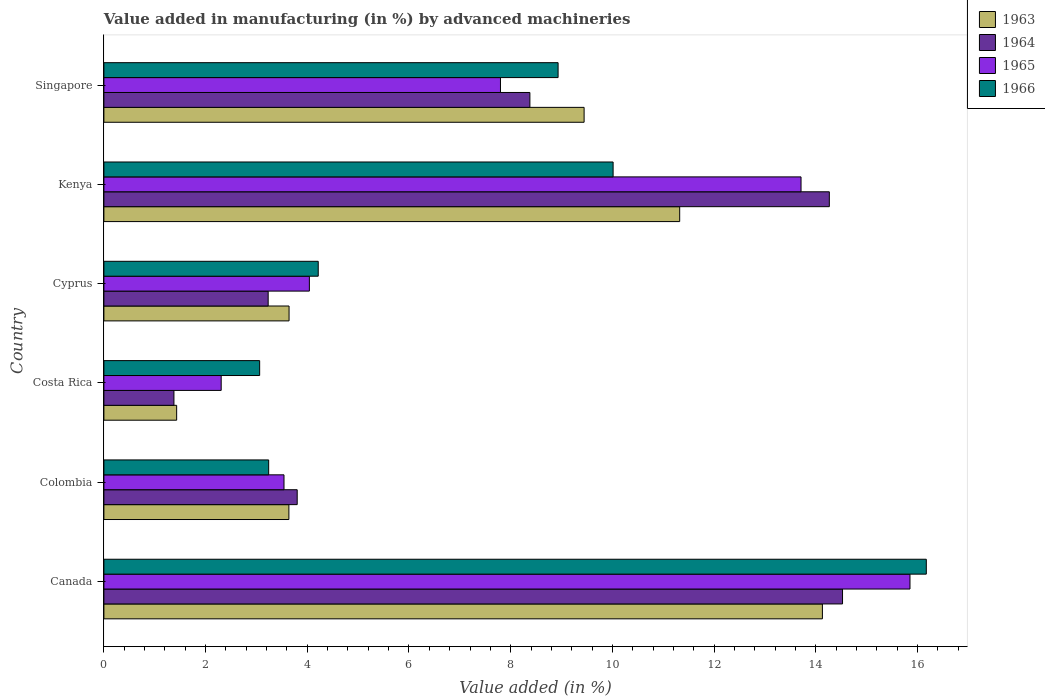How many groups of bars are there?
Offer a very short reply. 6. Are the number of bars on each tick of the Y-axis equal?
Your answer should be very brief. Yes. In how many cases, is the number of bars for a given country not equal to the number of legend labels?
Ensure brevity in your answer.  0. What is the percentage of value added in manufacturing by advanced machineries in 1964 in Canada?
Offer a terse response. 14.53. Across all countries, what is the maximum percentage of value added in manufacturing by advanced machineries in 1966?
Make the answer very short. 16.17. Across all countries, what is the minimum percentage of value added in manufacturing by advanced machineries in 1966?
Your response must be concise. 3.06. In which country was the percentage of value added in manufacturing by advanced machineries in 1965 maximum?
Your answer should be compact. Canada. What is the total percentage of value added in manufacturing by advanced machineries in 1963 in the graph?
Keep it short and to the point. 43.61. What is the difference between the percentage of value added in manufacturing by advanced machineries in 1966 in Canada and that in Singapore?
Offer a very short reply. 7.24. What is the difference between the percentage of value added in manufacturing by advanced machineries in 1966 in Costa Rica and the percentage of value added in manufacturing by advanced machineries in 1965 in Canada?
Give a very brief answer. -12.79. What is the average percentage of value added in manufacturing by advanced machineries in 1963 per country?
Offer a very short reply. 7.27. What is the difference between the percentage of value added in manufacturing by advanced machineries in 1964 and percentage of value added in manufacturing by advanced machineries in 1963 in Costa Rica?
Your answer should be compact. -0.05. In how many countries, is the percentage of value added in manufacturing by advanced machineries in 1964 greater than 12.4 %?
Make the answer very short. 2. What is the ratio of the percentage of value added in manufacturing by advanced machineries in 1966 in Cyprus to that in Singapore?
Your answer should be very brief. 0.47. Is the percentage of value added in manufacturing by advanced machineries in 1966 in Colombia less than that in Singapore?
Your answer should be very brief. Yes. Is the difference between the percentage of value added in manufacturing by advanced machineries in 1964 in Cyprus and Kenya greater than the difference between the percentage of value added in manufacturing by advanced machineries in 1963 in Cyprus and Kenya?
Your response must be concise. No. What is the difference between the highest and the second highest percentage of value added in manufacturing by advanced machineries in 1964?
Your answer should be very brief. 0.26. What is the difference between the highest and the lowest percentage of value added in manufacturing by advanced machineries in 1963?
Keep it short and to the point. 12.7. Is the sum of the percentage of value added in manufacturing by advanced machineries in 1964 in Kenya and Singapore greater than the maximum percentage of value added in manufacturing by advanced machineries in 1966 across all countries?
Ensure brevity in your answer.  Yes. Is it the case that in every country, the sum of the percentage of value added in manufacturing by advanced machineries in 1963 and percentage of value added in manufacturing by advanced machineries in 1964 is greater than the sum of percentage of value added in manufacturing by advanced machineries in 1965 and percentage of value added in manufacturing by advanced machineries in 1966?
Give a very brief answer. No. What does the 2nd bar from the top in Costa Rica represents?
Keep it short and to the point. 1965. What does the 3rd bar from the bottom in Kenya represents?
Give a very brief answer. 1965. How many countries are there in the graph?
Your answer should be compact. 6. Are the values on the major ticks of X-axis written in scientific E-notation?
Give a very brief answer. No. How many legend labels are there?
Provide a short and direct response. 4. What is the title of the graph?
Your answer should be very brief. Value added in manufacturing (in %) by advanced machineries. Does "2003" appear as one of the legend labels in the graph?
Offer a very short reply. No. What is the label or title of the X-axis?
Offer a very short reply. Value added (in %). What is the label or title of the Y-axis?
Your response must be concise. Country. What is the Value added (in %) of 1963 in Canada?
Make the answer very short. 14.13. What is the Value added (in %) of 1964 in Canada?
Keep it short and to the point. 14.53. What is the Value added (in %) of 1965 in Canada?
Make the answer very short. 15.85. What is the Value added (in %) in 1966 in Canada?
Keep it short and to the point. 16.17. What is the Value added (in %) of 1963 in Colombia?
Offer a terse response. 3.64. What is the Value added (in %) of 1964 in Colombia?
Your answer should be very brief. 3.8. What is the Value added (in %) in 1965 in Colombia?
Offer a very short reply. 3.54. What is the Value added (in %) of 1966 in Colombia?
Give a very brief answer. 3.24. What is the Value added (in %) in 1963 in Costa Rica?
Ensure brevity in your answer.  1.43. What is the Value added (in %) of 1964 in Costa Rica?
Your response must be concise. 1.38. What is the Value added (in %) of 1965 in Costa Rica?
Offer a terse response. 2.31. What is the Value added (in %) in 1966 in Costa Rica?
Your answer should be very brief. 3.06. What is the Value added (in %) of 1963 in Cyprus?
Provide a short and direct response. 3.64. What is the Value added (in %) of 1964 in Cyprus?
Offer a terse response. 3.23. What is the Value added (in %) of 1965 in Cyprus?
Keep it short and to the point. 4.04. What is the Value added (in %) in 1966 in Cyprus?
Your response must be concise. 4.22. What is the Value added (in %) in 1963 in Kenya?
Make the answer very short. 11.32. What is the Value added (in %) of 1964 in Kenya?
Provide a succinct answer. 14.27. What is the Value added (in %) of 1965 in Kenya?
Your response must be concise. 13.71. What is the Value added (in %) of 1966 in Kenya?
Offer a very short reply. 10.01. What is the Value added (in %) in 1963 in Singapore?
Give a very brief answer. 9.44. What is the Value added (in %) in 1964 in Singapore?
Your answer should be very brief. 8.38. What is the Value added (in %) of 1965 in Singapore?
Provide a short and direct response. 7.8. What is the Value added (in %) of 1966 in Singapore?
Offer a terse response. 8.93. Across all countries, what is the maximum Value added (in %) in 1963?
Keep it short and to the point. 14.13. Across all countries, what is the maximum Value added (in %) in 1964?
Offer a terse response. 14.53. Across all countries, what is the maximum Value added (in %) of 1965?
Your answer should be very brief. 15.85. Across all countries, what is the maximum Value added (in %) of 1966?
Keep it short and to the point. 16.17. Across all countries, what is the minimum Value added (in %) in 1963?
Ensure brevity in your answer.  1.43. Across all countries, what is the minimum Value added (in %) in 1964?
Keep it short and to the point. 1.38. Across all countries, what is the minimum Value added (in %) of 1965?
Your answer should be compact. 2.31. Across all countries, what is the minimum Value added (in %) of 1966?
Ensure brevity in your answer.  3.06. What is the total Value added (in %) in 1963 in the graph?
Give a very brief answer. 43.61. What is the total Value added (in %) in 1964 in the graph?
Provide a short and direct response. 45.58. What is the total Value added (in %) in 1965 in the graph?
Make the answer very short. 47.25. What is the total Value added (in %) in 1966 in the graph?
Your response must be concise. 45.64. What is the difference between the Value added (in %) in 1963 in Canada and that in Colombia?
Offer a very short reply. 10.49. What is the difference between the Value added (in %) in 1964 in Canada and that in Colombia?
Keep it short and to the point. 10.72. What is the difference between the Value added (in %) in 1965 in Canada and that in Colombia?
Make the answer very short. 12.31. What is the difference between the Value added (in %) in 1966 in Canada and that in Colombia?
Provide a succinct answer. 12.93. What is the difference between the Value added (in %) of 1963 in Canada and that in Costa Rica?
Your answer should be very brief. 12.7. What is the difference between the Value added (in %) in 1964 in Canada and that in Costa Rica?
Give a very brief answer. 13.15. What is the difference between the Value added (in %) in 1965 in Canada and that in Costa Rica?
Offer a terse response. 13.55. What is the difference between the Value added (in %) in 1966 in Canada and that in Costa Rica?
Give a very brief answer. 13.11. What is the difference between the Value added (in %) of 1963 in Canada and that in Cyprus?
Make the answer very short. 10.49. What is the difference between the Value added (in %) of 1964 in Canada and that in Cyprus?
Provide a short and direct response. 11.3. What is the difference between the Value added (in %) of 1965 in Canada and that in Cyprus?
Your response must be concise. 11.81. What is the difference between the Value added (in %) in 1966 in Canada and that in Cyprus?
Your response must be concise. 11.96. What is the difference between the Value added (in %) in 1963 in Canada and that in Kenya?
Offer a very short reply. 2.81. What is the difference between the Value added (in %) of 1964 in Canada and that in Kenya?
Keep it short and to the point. 0.26. What is the difference between the Value added (in %) in 1965 in Canada and that in Kenya?
Offer a terse response. 2.14. What is the difference between the Value added (in %) of 1966 in Canada and that in Kenya?
Your response must be concise. 6.16. What is the difference between the Value added (in %) in 1963 in Canada and that in Singapore?
Your answer should be compact. 4.69. What is the difference between the Value added (in %) of 1964 in Canada and that in Singapore?
Make the answer very short. 6.15. What is the difference between the Value added (in %) of 1965 in Canada and that in Singapore?
Offer a terse response. 8.05. What is the difference between the Value added (in %) of 1966 in Canada and that in Singapore?
Keep it short and to the point. 7.24. What is the difference between the Value added (in %) of 1963 in Colombia and that in Costa Rica?
Your answer should be very brief. 2.21. What is the difference between the Value added (in %) in 1964 in Colombia and that in Costa Rica?
Your response must be concise. 2.42. What is the difference between the Value added (in %) of 1965 in Colombia and that in Costa Rica?
Ensure brevity in your answer.  1.24. What is the difference between the Value added (in %) in 1966 in Colombia and that in Costa Rica?
Ensure brevity in your answer.  0.18. What is the difference between the Value added (in %) of 1963 in Colombia and that in Cyprus?
Provide a short and direct response. -0. What is the difference between the Value added (in %) of 1964 in Colombia and that in Cyprus?
Provide a succinct answer. 0.57. What is the difference between the Value added (in %) in 1965 in Colombia and that in Cyprus?
Offer a terse response. -0.5. What is the difference between the Value added (in %) of 1966 in Colombia and that in Cyprus?
Your answer should be very brief. -0.97. What is the difference between the Value added (in %) in 1963 in Colombia and that in Kenya?
Your answer should be very brief. -7.69. What is the difference between the Value added (in %) of 1964 in Colombia and that in Kenya?
Offer a very short reply. -10.47. What is the difference between the Value added (in %) of 1965 in Colombia and that in Kenya?
Offer a terse response. -10.17. What is the difference between the Value added (in %) in 1966 in Colombia and that in Kenya?
Ensure brevity in your answer.  -6.77. What is the difference between the Value added (in %) of 1963 in Colombia and that in Singapore?
Offer a very short reply. -5.81. What is the difference between the Value added (in %) of 1964 in Colombia and that in Singapore?
Your response must be concise. -4.58. What is the difference between the Value added (in %) in 1965 in Colombia and that in Singapore?
Make the answer very short. -4.26. What is the difference between the Value added (in %) in 1966 in Colombia and that in Singapore?
Your answer should be compact. -5.69. What is the difference between the Value added (in %) in 1963 in Costa Rica and that in Cyprus?
Provide a short and direct response. -2.21. What is the difference between the Value added (in %) in 1964 in Costa Rica and that in Cyprus?
Offer a terse response. -1.85. What is the difference between the Value added (in %) in 1965 in Costa Rica and that in Cyprus?
Your response must be concise. -1.73. What is the difference between the Value added (in %) in 1966 in Costa Rica and that in Cyprus?
Keep it short and to the point. -1.15. What is the difference between the Value added (in %) in 1963 in Costa Rica and that in Kenya?
Offer a terse response. -9.89. What is the difference between the Value added (in %) in 1964 in Costa Rica and that in Kenya?
Give a very brief answer. -12.89. What is the difference between the Value added (in %) in 1965 in Costa Rica and that in Kenya?
Offer a very short reply. -11.4. What is the difference between the Value added (in %) in 1966 in Costa Rica and that in Kenya?
Your answer should be compact. -6.95. What is the difference between the Value added (in %) in 1963 in Costa Rica and that in Singapore?
Provide a short and direct response. -8.01. What is the difference between the Value added (in %) in 1964 in Costa Rica and that in Singapore?
Ensure brevity in your answer.  -7. What is the difference between the Value added (in %) of 1965 in Costa Rica and that in Singapore?
Provide a succinct answer. -5.49. What is the difference between the Value added (in %) of 1966 in Costa Rica and that in Singapore?
Your answer should be compact. -5.87. What is the difference between the Value added (in %) in 1963 in Cyprus and that in Kenya?
Offer a very short reply. -7.68. What is the difference between the Value added (in %) of 1964 in Cyprus and that in Kenya?
Ensure brevity in your answer.  -11.04. What is the difference between the Value added (in %) of 1965 in Cyprus and that in Kenya?
Ensure brevity in your answer.  -9.67. What is the difference between the Value added (in %) in 1966 in Cyprus and that in Kenya?
Offer a terse response. -5.8. What is the difference between the Value added (in %) in 1963 in Cyprus and that in Singapore?
Provide a short and direct response. -5.8. What is the difference between the Value added (in %) in 1964 in Cyprus and that in Singapore?
Your response must be concise. -5.15. What is the difference between the Value added (in %) in 1965 in Cyprus and that in Singapore?
Offer a terse response. -3.76. What is the difference between the Value added (in %) of 1966 in Cyprus and that in Singapore?
Ensure brevity in your answer.  -4.72. What is the difference between the Value added (in %) of 1963 in Kenya and that in Singapore?
Give a very brief answer. 1.88. What is the difference between the Value added (in %) in 1964 in Kenya and that in Singapore?
Your answer should be very brief. 5.89. What is the difference between the Value added (in %) in 1965 in Kenya and that in Singapore?
Your response must be concise. 5.91. What is the difference between the Value added (in %) of 1966 in Kenya and that in Singapore?
Ensure brevity in your answer.  1.08. What is the difference between the Value added (in %) of 1963 in Canada and the Value added (in %) of 1964 in Colombia?
Your answer should be very brief. 10.33. What is the difference between the Value added (in %) of 1963 in Canada and the Value added (in %) of 1965 in Colombia?
Give a very brief answer. 10.59. What is the difference between the Value added (in %) of 1963 in Canada and the Value added (in %) of 1966 in Colombia?
Provide a succinct answer. 10.89. What is the difference between the Value added (in %) of 1964 in Canada and the Value added (in %) of 1965 in Colombia?
Make the answer very short. 10.98. What is the difference between the Value added (in %) in 1964 in Canada and the Value added (in %) in 1966 in Colombia?
Make the answer very short. 11.29. What is the difference between the Value added (in %) of 1965 in Canada and the Value added (in %) of 1966 in Colombia?
Provide a succinct answer. 12.61. What is the difference between the Value added (in %) of 1963 in Canada and the Value added (in %) of 1964 in Costa Rica?
Keep it short and to the point. 12.75. What is the difference between the Value added (in %) of 1963 in Canada and the Value added (in %) of 1965 in Costa Rica?
Ensure brevity in your answer.  11.82. What is the difference between the Value added (in %) of 1963 in Canada and the Value added (in %) of 1966 in Costa Rica?
Provide a short and direct response. 11.07. What is the difference between the Value added (in %) in 1964 in Canada and the Value added (in %) in 1965 in Costa Rica?
Offer a terse response. 12.22. What is the difference between the Value added (in %) in 1964 in Canada and the Value added (in %) in 1966 in Costa Rica?
Ensure brevity in your answer.  11.46. What is the difference between the Value added (in %) in 1965 in Canada and the Value added (in %) in 1966 in Costa Rica?
Provide a short and direct response. 12.79. What is the difference between the Value added (in %) in 1963 in Canada and the Value added (in %) in 1964 in Cyprus?
Your answer should be very brief. 10.9. What is the difference between the Value added (in %) of 1963 in Canada and the Value added (in %) of 1965 in Cyprus?
Your response must be concise. 10.09. What is the difference between the Value added (in %) in 1963 in Canada and the Value added (in %) in 1966 in Cyprus?
Your answer should be very brief. 9.92. What is the difference between the Value added (in %) in 1964 in Canada and the Value added (in %) in 1965 in Cyprus?
Make the answer very short. 10.49. What is the difference between the Value added (in %) of 1964 in Canada and the Value added (in %) of 1966 in Cyprus?
Your answer should be compact. 10.31. What is the difference between the Value added (in %) in 1965 in Canada and the Value added (in %) in 1966 in Cyprus?
Give a very brief answer. 11.64. What is the difference between the Value added (in %) in 1963 in Canada and the Value added (in %) in 1964 in Kenya?
Offer a terse response. -0.14. What is the difference between the Value added (in %) of 1963 in Canada and the Value added (in %) of 1965 in Kenya?
Provide a short and direct response. 0.42. What is the difference between the Value added (in %) in 1963 in Canada and the Value added (in %) in 1966 in Kenya?
Give a very brief answer. 4.12. What is the difference between the Value added (in %) in 1964 in Canada and the Value added (in %) in 1965 in Kenya?
Give a very brief answer. 0.82. What is the difference between the Value added (in %) in 1964 in Canada and the Value added (in %) in 1966 in Kenya?
Provide a succinct answer. 4.51. What is the difference between the Value added (in %) of 1965 in Canada and the Value added (in %) of 1966 in Kenya?
Offer a very short reply. 5.84. What is the difference between the Value added (in %) in 1963 in Canada and the Value added (in %) in 1964 in Singapore?
Provide a succinct answer. 5.75. What is the difference between the Value added (in %) of 1963 in Canada and the Value added (in %) of 1965 in Singapore?
Give a very brief answer. 6.33. What is the difference between the Value added (in %) in 1963 in Canada and the Value added (in %) in 1966 in Singapore?
Your answer should be compact. 5.2. What is the difference between the Value added (in %) of 1964 in Canada and the Value added (in %) of 1965 in Singapore?
Offer a very short reply. 6.73. What is the difference between the Value added (in %) in 1964 in Canada and the Value added (in %) in 1966 in Singapore?
Your answer should be compact. 5.59. What is the difference between the Value added (in %) in 1965 in Canada and the Value added (in %) in 1966 in Singapore?
Give a very brief answer. 6.92. What is the difference between the Value added (in %) of 1963 in Colombia and the Value added (in %) of 1964 in Costa Rica?
Your answer should be very brief. 2.26. What is the difference between the Value added (in %) in 1963 in Colombia and the Value added (in %) in 1965 in Costa Rica?
Provide a short and direct response. 1.33. What is the difference between the Value added (in %) in 1963 in Colombia and the Value added (in %) in 1966 in Costa Rica?
Provide a succinct answer. 0.57. What is the difference between the Value added (in %) of 1964 in Colombia and the Value added (in %) of 1965 in Costa Rica?
Your answer should be compact. 1.49. What is the difference between the Value added (in %) of 1964 in Colombia and the Value added (in %) of 1966 in Costa Rica?
Ensure brevity in your answer.  0.74. What is the difference between the Value added (in %) of 1965 in Colombia and the Value added (in %) of 1966 in Costa Rica?
Ensure brevity in your answer.  0.48. What is the difference between the Value added (in %) in 1963 in Colombia and the Value added (in %) in 1964 in Cyprus?
Ensure brevity in your answer.  0.41. What is the difference between the Value added (in %) of 1963 in Colombia and the Value added (in %) of 1965 in Cyprus?
Make the answer very short. -0.4. What is the difference between the Value added (in %) of 1963 in Colombia and the Value added (in %) of 1966 in Cyprus?
Your response must be concise. -0.58. What is the difference between the Value added (in %) of 1964 in Colombia and the Value added (in %) of 1965 in Cyprus?
Your response must be concise. -0.24. What is the difference between the Value added (in %) of 1964 in Colombia and the Value added (in %) of 1966 in Cyprus?
Provide a short and direct response. -0.41. What is the difference between the Value added (in %) in 1965 in Colombia and the Value added (in %) in 1966 in Cyprus?
Offer a terse response. -0.67. What is the difference between the Value added (in %) of 1963 in Colombia and the Value added (in %) of 1964 in Kenya?
Your answer should be very brief. -10.63. What is the difference between the Value added (in %) in 1963 in Colombia and the Value added (in %) in 1965 in Kenya?
Your answer should be compact. -10.07. What is the difference between the Value added (in %) in 1963 in Colombia and the Value added (in %) in 1966 in Kenya?
Provide a succinct answer. -6.38. What is the difference between the Value added (in %) in 1964 in Colombia and the Value added (in %) in 1965 in Kenya?
Make the answer very short. -9.91. What is the difference between the Value added (in %) of 1964 in Colombia and the Value added (in %) of 1966 in Kenya?
Provide a succinct answer. -6.21. What is the difference between the Value added (in %) of 1965 in Colombia and the Value added (in %) of 1966 in Kenya?
Make the answer very short. -6.47. What is the difference between the Value added (in %) in 1963 in Colombia and the Value added (in %) in 1964 in Singapore?
Your answer should be compact. -4.74. What is the difference between the Value added (in %) of 1963 in Colombia and the Value added (in %) of 1965 in Singapore?
Your answer should be very brief. -4.16. What is the difference between the Value added (in %) in 1963 in Colombia and the Value added (in %) in 1966 in Singapore?
Your answer should be very brief. -5.29. What is the difference between the Value added (in %) in 1964 in Colombia and the Value added (in %) in 1965 in Singapore?
Your response must be concise. -4. What is the difference between the Value added (in %) of 1964 in Colombia and the Value added (in %) of 1966 in Singapore?
Make the answer very short. -5.13. What is the difference between the Value added (in %) of 1965 in Colombia and the Value added (in %) of 1966 in Singapore?
Your response must be concise. -5.39. What is the difference between the Value added (in %) in 1963 in Costa Rica and the Value added (in %) in 1964 in Cyprus?
Your response must be concise. -1.8. What is the difference between the Value added (in %) in 1963 in Costa Rica and the Value added (in %) in 1965 in Cyprus?
Make the answer very short. -2.61. What is the difference between the Value added (in %) in 1963 in Costa Rica and the Value added (in %) in 1966 in Cyprus?
Keep it short and to the point. -2.78. What is the difference between the Value added (in %) in 1964 in Costa Rica and the Value added (in %) in 1965 in Cyprus?
Give a very brief answer. -2.66. What is the difference between the Value added (in %) of 1964 in Costa Rica and the Value added (in %) of 1966 in Cyprus?
Provide a short and direct response. -2.84. What is the difference between the Value added (in %) of 1965 in Costa Rica and the Value added (in %) of 1966 in Cyprus?
Your answer should be very brief. -1.91. What is the difference between the Value added (in %) in 1963 in Costa Rica and the Value added (in %) in 1964 in Kenya?
Make the answer very short. -12.84. What is the difference between the Value added (in %) in 1963 in Costa Rica and the Value added (in %) in 1965 in Kenya?
Give a very brief answer. -12.28. What is the difference between the Value added (in %) in 1963 in Costa Rica and the Value added (in %) in 1966 in Kenya?
Make the answer very short. -8.58. What is the difference between the Value added (in %) of 1964 in Costa Rica and the Value added (in %) of 1965 in Kenya?
Give a very brief answer. -12.33. What is the difference between the Value added (in %) of 1964 in Costa Rica and the Value added (in %) of 1966 in Kenya?
Provide a short and direct response. -8.64. What is the difference between the Value added (in %) in 1965 in Costa Rica and the Value added (in %) in 1966 in Kenya?
Give a very brief answer. -7.71. What is the difference between the Value added (in %) of 1963 in Costa Rica and the Value added (in %) of 1964 in Singapore?
Provide a short and direct response. -6.95. What is the difference between the Value added (in %) in 1963 in Costa Rica and the Value added (in %) in 1965 in Singapore?
Provide a succinct answer. -6.37. What is the difference between the Value added (in %) of 1963 in Costa Rica and the Value added (in %) of 1966 in Singapore?
Provide a succinct answer. -7.5. What is the difference between the Value added (in %) in 1964 in Costa Rica and the Value added (in %) in 1965 in Singapore?
Ensure brevity in your answer.  -6.42. What is the difference between the Value added (in %) of 1964 in Costa Rica and the Value added (in %) of 1966 in Singapore?
Keep it short and to the point. -7.55. What is the difference between the Value added (in %) of 1965 in Costa Rica and the Value added (in %) of 1966 in Singapore?
Your response must be concise. -6.63. What is the difference between the Value added (in %) in 1963 in Cyprus and the Value added (in %) in 1964 in Kenya?
Offer a terse response. -10.63. What is the difference between the Value added (in %) in 1963 in Cyprus and the Value added (in %) in 1965 in Kenya?
Offer a terse response. -10.07. What is the difference between the Value added (in %) in 1963 in Cyprus and the Value added (in %) in 1966 in Kenya?
Your response must be concise. -6.37. What is the difference between the Value added (in %) of 1964 in Cyprus and the Value added (in %) of 1965 in Kenya?
Make the answer very short. -10.48. What is the difference between the Value added (in %) in 1964 in Cyprus and the Value added (in %) in 1966 in Kenya?
Ensure brevity in your answer.  -6.78. What is the difference between the Value added (in %) of 1965 in Cyprus and the Value added (in %) of 1966 in Kenya?
Offer a very short reply. -5.97. What is the difference between the Value added (in %) of 1963 in Cyprus and the Value added (in %) of 1964 in Singapore?
Provide a succinct answer. -4.74. What is the difference between the Value added (in %) in 1963 in Cyprus and the Value added (in %) in 1965 in Singapore?
Your response must be concise. -4.16. What is the difference between the Value added (in %) of 1963 in Cyprus and the Value added (in %) of 1966 in Singapore?
Offer a terse response. -5.29. What is the difference between the Value added (in %) of 1964 in Cyprus and the Value added (in %) of 1965 in Singapore?
Your response must be concise. -4.57. What is the difference between the Value added (in %) of 1964 in Cyprus and the Value added (in %) of 1966 in Singapore?
Provide a succinct answer. -5.7. What is the difference between the Value added (in %) of 1965 in Cyprus and the Value added (in %) of 1966 in Singapore?
Your answer should be compact. -4.89. What is the difference between the Value added (in %) in 1963 in Kenya and the Value added (in %) in 1964 in Singapore?
Provide a succinct answer. 2.95. What is the difference between the Value added (in %) in 1963 in Kenya and the Value added (in %) in 1965 in Singapore?
Offer a terse response. 3.52. What is the difference between the Value added (in %) of 1963 in Kenya and the Value added (in %) of 1966 in Singapore?
Provide a succinct answer. 2.39. What is the difference between the Value added (in %) in 1964 in Kenya and the Value added (in %) in 1965 in Singapore?
Your answer should be very brief. 6.47. What is the difference between the Value added (in %) in 1964 in Kenya and the Value added (in %) in 1966 in Singapore?
Offer a terse response. 5.33. What is the difference between the Value added (in %) of 1965 in Kenya and the Value added (in %) of 1966 in Singapore?
Give a very brief answer. 4.78. What is the average Value added (in %) in 1963 per country?
Ensure brevity in your answer.  7.27. What is the average Value added (in %) in 1964 per country?
Offer a terse response. 7.6. What is the average Value added (in %) of 1965 per country?
Ensure brevity in your answer.  7.88. What is the average Value added (in %) of 1966 per country?
Your answer should be compact. 7.61. What is the difference between the Value added (in %) of 1963 and Value added (in %) of 1964 in Canada?
Your answer should be very brief. -0.4. What is the difference between the Value added (in %) of 1963 and Value added (in %) of 1965 in Canada?
Provide a short and direct response. -1.72. What is the difference between the Value added (in %) of 1963 and Value added (in %) of 1966 in Canada?
Make the answer very short. -2.04. What is the difference between the Value added (in %) in 1964 and Value added (in %) in 1965 in Canada?
Your response must be concise. -1.33. What is the difference between the Value added (in %) of 1964 and Value added (in %) of 1966 in Canada?
Offer a very short reply. -1.65. What is the difference between the Value added (in %) in 1965 and Value added (in %) in 1966 in Canada?
Provide a succinct answer. -0.32. What is the difference between the Value added (in %) of 1963 and Value added (in %) of 1964 in Colombia?
Make the answer very short. -0.16. What is the difference between the Value added (in %) in 1963 and Value added (in %) in 1965 in Colombia?
Offer a very short reply. 0.1. What is the difference between the Value added (in %) in 1963 and Value added (in %) in 1966 in Colombia?
Your response must be concise. 0.4. What is the difference between the Value added (in %) of 1964 and Value added (in %) of 1965 in Colombia?
Provide a short and direct response. 0.26. What is the difference between the Value added (in %) in 1964 and Value added (in %) in 1966 in Colombia?
Provide a succinct answer. 0.56. What is the difference between the Value added (in %) in 1965 and Value added (in %) in 1966 in Colombia?
Offer a terse response. 0.3. What is the difference between the Value added (in %) of 1963 and Value added (in %) of 1964 in Costa Rica?
Keep it short and to the point. 0.05. What is the difference between the Value added (in %) of 1963 and Value added (in %) of 1965 in Costa Rica?
Offer a terse response. -0.88. What is the difference between the Value added (in %) of 1963 and Value added (in %) of 1966 in Costa Rica?
Offer a terse response. -1.63. What is the difference between the Value added (in %) of 1964 and Value added (in %) of 1965 in Costa Rica?
Offer a terse response. -0.93. What is the difference between the Value added (in %) in 1964 and Value added (in %) in 1966 in Costa Rica?
Your response must be concise. -1.69. What is the difference between the Value added (in %) in 1965 and Value added (in %) in 1966 in Costa Rica?
Your answer should be very brief. -0.76. What is the difference between the Value added (in %) of 1963 and Value added (in %) of 1964 in Cyprus?
Provide a short and direct response. 0.41. What is the difference between the Value added (in %) in 1963 and Value added (in %) in 1965 in Cyprus?
Keep it short and to the point. -0.4. What is the difference between the Value added (in %) in 1963 and Value added (in %) in 1966 in Cyprus?
Provide a short and direct response. -0.57. What is the difference between the Value added (in %) of 1964 and Value added (in %) of 1965 in Cyprus?
Your answer should be very brief. -0.81. What is the difference between the Value added (in %) in 1964 and Value added (in %) in 1966 in Cyprus?
Your answer should be very brief. -0.98. What is the difference between the Value added (in %) in 1965 and Value added (in %) in 1966 in Cyprus?
Offer a very short reply. -0.17. What is the difference between the Value added (in %) in 1963 and Value added (in %) in 1964 in Kenya?
Ensure brevity in your answer.  -2.94. What is the difference between the Value added (in %) in 1963 and Value added (in %) in 1965 in Kenya?
Make the answer very short. -2.39. What is the difference between the Value added (in %) of 1963 and Value added (in %) of 1966 in Kenya?
Your response must be concise. 1.31. What is the difference between the Value added (in %) of 1964 and Value added (in %) of 1965 in Kenya?
Offer a very short reply. 0.56. What is the difference between the Value added (in %) in 1964 and Value added (in %) in 1966 in Kenya?
Give a very brief answer. 4.25. What is the difference between the Value added (in %) in 1965 and Value added (in %) in 1966 in Kenya?
Provide a short and direct response. 3.7. What is the difference between the Value added (in %) in 1963 and Value added (in %) in 1964 in Singapore?
Your response must be concise. 1.07. What is the difference between the Value added (in %) in 1963 and Value added (in %) in 1965 in Singapore?
Offer a terse response. 1.64. What is the difference between the Value added (in %) in 1963 and Value added (in %) in 1966 in Singapore?
Provide a succinct answer. 0.51. What is the difference between the Value added (in %) in 1964 and Value added (in %) in 1965 in Singapore?
Make the answer very short. 0.58. What is the difference between the Value added (in %) in 1964 and Value added (in %) in 1966 in Singapore?
Your answer should be compact. -0.55. What is the difference between the Value added (in %) in 1965 and Value added (in %) in 1966 in Singapore?
Keep it short and to the point. -1.13. What is the ratio of the Value added (in %) in 1963 in Canada to that in Colombia?
Offer a terse response. 3.88. What is the ratio of the Value added (in %) of 1964 in Canada to that in Colombia?
Your answer should be very brief. 3.82. What is the ratio of the Value added (in %) in 1965 in Canada to that in Colombia?
Offer a very short reply. 4.48. What is the ratio of the Value added (in %) of 1966 in Canada to that in Colombia?
Provide a succinct answer. 4.99. What is the ratio of the Value added (in %) of 1963 in Canada to that in Costa Rica?
Keep it short and to the point. 9.87. What is the ratio of the Value added (in %) of 1964 in Canada to that in Costa Rica?
Keep it short and to the point. 10.54. What is the ratio of the Value added (in %) in 1965 in Canada to that in Costa Rica?
Offer a very short reply. 6.87. What is the ratio of the Value added (in %) of 1966 in Canada to that in Costa Rica?
Make the answer very short. 5.28. What is the ratio of the Value added (in %) in 1963 in Canada to that in Cyprus?
Ensure brevity in your answer.  3.88. What is the ratio of the Value added (in %) of 1964 in Canada to that in Cyprus?
Offer a terse response. 4.5. What is the ratio of the Value added (in %) of 1965 in Canada to that in Cyprus?
Make the answer very short. 3.92. What is the ratio of the Value added (in %) in 1966 in Canada to that in Cyprus?
Provide a succinct answer. 3.84. What is the ratio of the Value added (in %) in 1963 in Canada to that in Kenya?
Provide a short and direct response. 1.25. What is the ratio of the Value added (in %) in 1964 in Canada to that in Kenya?
Keep it short and to the point. 1.02. What is the ratio of the Value added (in %) in 1965 in Canada to that in Kenya?
Keep it short and to the point. 1.16. What is the ratio of the Value added (in %) in 1966 in Canada to that in Kenya?
Keep it short and to the point. 1.62. What is the ratio of the Value added (in %) of 1963 in Canada to that in Singapore?
Provide a succinct answer. 1.5. What is the ratio of the Value added (in %) in 1964 in Canada to that in Singapore?
Your response must be concise. 1.73. What is the ratio of the Value added (in %) in 1965 in Canada to that in Singapore?
Give a very brief answer. 2.03. What is the ratio of the Value added (in %) of 1966 in Canada to that in Singapore?
Offer a very short reply. 1.81. What is the ratio of the Value added (in %) in 1963 in Colombia to that in Costa Rica?
Offer a terse response. 2.54. What is the ratio of the Value added (in %) of 1964 in Colombia to that in Costa Rica?
Your response must be concise. 2.76. What is the ratio of the Value added (in %) in 1965 in Colombia to that in Costa Rica?
Give a very brief answer. 1.54. What is the ratio of the Value added (in %) of 1966 in Colombia to that in Costa Rica?
Provide a short and direct response. 1.06. What is the ratio of the Value added (in %) of 1964 in Colombia to that in Cyprus?
Offer a very short reply. 1.18. What is the ratio of the Value added (in %) in 1965 in Colombia to that in Cyprus?
Offer a terse response. 0.88. What is the ratio of the Value added (in %) in 1966 in Colombia to that in Cyprus?
Offer a terse response. 0.77. What is the ratio of the Value added (in %) in 1963 in Colombia to that in Kenya?
Offer a very short reply. 0.32. What is the ratio of the Value added (in %) of 1964 in Colombia to that in Kenya?
Make the answer very short. 0.27. What is the ratio of the Value added (in %) of 1965 in Colombia to that in Kenya?
Your answer should be very brief. 0.26. What is the ratio of the Value added (in %) in 1966 in Colombia to that in Kenya?
Provide a succinct answer. 0.32. What is the ratio of the Value added (in %) in 1963 in Colombia to that in Singapore?
Your response must be concise. 0.39. What is the ratio of the Value added (in %) of 1964 in Colombia to that in Singapore?
Offer a terse response. 0.45. What is the ratio of the Value added (in %) in 1965 in Colombia to that in Singapore?
Give a very brief answer. 0.45. What is the ratio of the Value added (in %) in 1966 in Colombia to that in Singapore?
Provide a short and direct response. 0.36. What is the ratio of the Value added (in %) of 1963 in Costa Rica to that in Cyprus?
Your answer should be compact. 0.39. What is the ratio of the Value added (in %) in 1964 in Costa Rica to that in Cyprus?
Your response must be concise. 0.43. What is the ratio of the Value added (in %) in 1965 in Costa Rica to that in Cyprus?
Provide a succinct answer. 0.57. What is the ratio of the Value added (in %) of 1966 in Costa Rica to that in Cyprus?
Offer a very short reply. 0.73. What is the ratio of the Value added (in %) of 1963 in Costa Rica to that in Kenya?
Keep it short and to the point. 0.13. What is the ratio of the Value added (in %) in 1964 in Costa Rica to that in Kenya?
Offer a terse response. 0.1. What is the ratio of the Value added (in %) in 1965 in Costa Rica to that in Kenya?
Provide a short and direct response. 0.17. What is the ratio of the Value added (in %) of 1966 in Costa Rica to that in Kenya?
Offer a very short reply. 0.31. What is the ratio of the Value added (in %) in 1963 in Costa Rica to that in Singapore?
Make the answer very short. 0.15. What is the ratio of the Value added (in %) in 1964 in Costa Rica to that in Singapore?
Your answer should be compact. 0.16. What is the ratio of the Value added (in %) of 1965 in Costa Rica to that in Singapore?
Your answer should be very brief. 0.3. What is the ratio of the Value added (in %) of 1966 in Costa Rica to that in Singapore?
Provide a succinct answer. 0.34. What is the ratio of the Value added (in %) in 1963 in Cyprus to that in Kenya?
Keep it short and to the point. 0.32. What is the ratio of the Value added (in %) in 1964 in Cyprus to that in Kenya?
Your answer should be compact. 0.23. What is the ratio of the Value added (in %) of 1965 in Cyprus to that in Kenya?
Provide a short and direct response. 0.29. What is the ratio of the Value added (in %) in 1966 in Cyprus to that in Kenya?
Provide a short and direct response. 0.42. What is the ratio of the Value added (in %) of 1963 in Cyprus to that in Singapore?
Make the answer very short. 0.39. What is the ratio of the Value added (in %) of 1964 in Cyprus to that in Singapore?
Your answer should be compact. 0.39. What is the ratio of the Value added (in %) of 1965 in Cyprus to that in Singapore?
Keep it short and to the point. 0.52. What is the ratio of the Value added (in %) in 1966 in Cyprus to that in Singapore?
Keep it short and to the point. 0.47. What is the ratio of the Value added (in %) in 1963 in Kenya to that in Singapore?
Give a very brief answer. 1.2. What is the ratio of the Value added (in %) in 1964 in Kenya to that in Singapore?
Keep it short and to the point. 1.7. What is the ratio of the Value added (in %) of 1965 in Kenya to that in Singapore?
Keep it short and to the point. 1.76. What is the ratio of the Value added (in %) in 1966 in Kenya to that in Singapore?
Offer a terse response. 1.12. What is the difference between the highest and the second highest Value added (in %) of 1963?
Your answer should be very brief. 2.81. What is the difference between the highest and the second highest Value added (in %) of 1964?
Your answer should be compact. 0.26. What is the difference between the highest and the second highest Value added (in %) of 1965?
Your response must be concise. 2.14. What is the difference between the highest and the second highest Value added (in %) of 1966?
Your response must be concise. 6.16. What is the difference between the highest and the lowest Value added (in %) of 1963?
Your answer should be compact. 12.7. What is the difference between the highest and the lowest Value added (in %) of 1964?
Make the answer very short. 13.15. What is the difference between the highest and the lowest Value added (in %) of 1965?
Offer a very short reply. 13.55. What is the difference between the highest and the lowest Value added (in %) of 1966?
Ensure brevity in your answer.  13.11. 